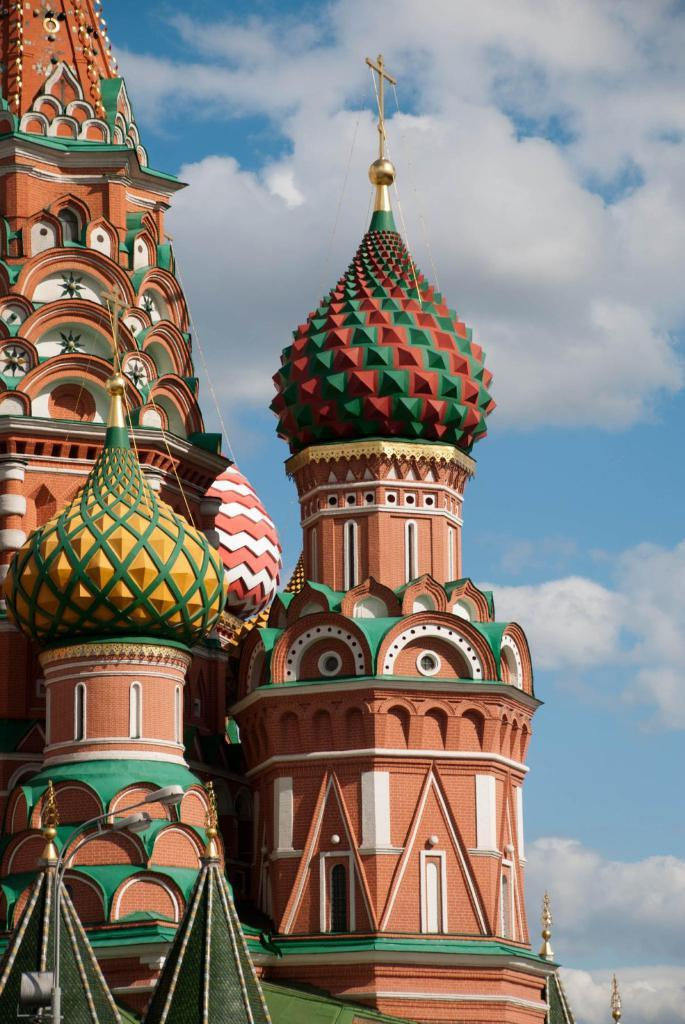What is the main structure in the front of the image? There is a building in the front of the image. What can be seen on the bottom left side of the image? There is a pole with two lights on the bottom left side of the image. What type of natural elements can be seen in the background of the image? There are clouds visible in the background of the image. What else is visible in the background of the image? The sky is visible in the background of the image. What type of waves can be seen crashing on the shore in the image? There are no waves or shore visible in the image; it features a building, a pole with lights, clouds, and the sky. 